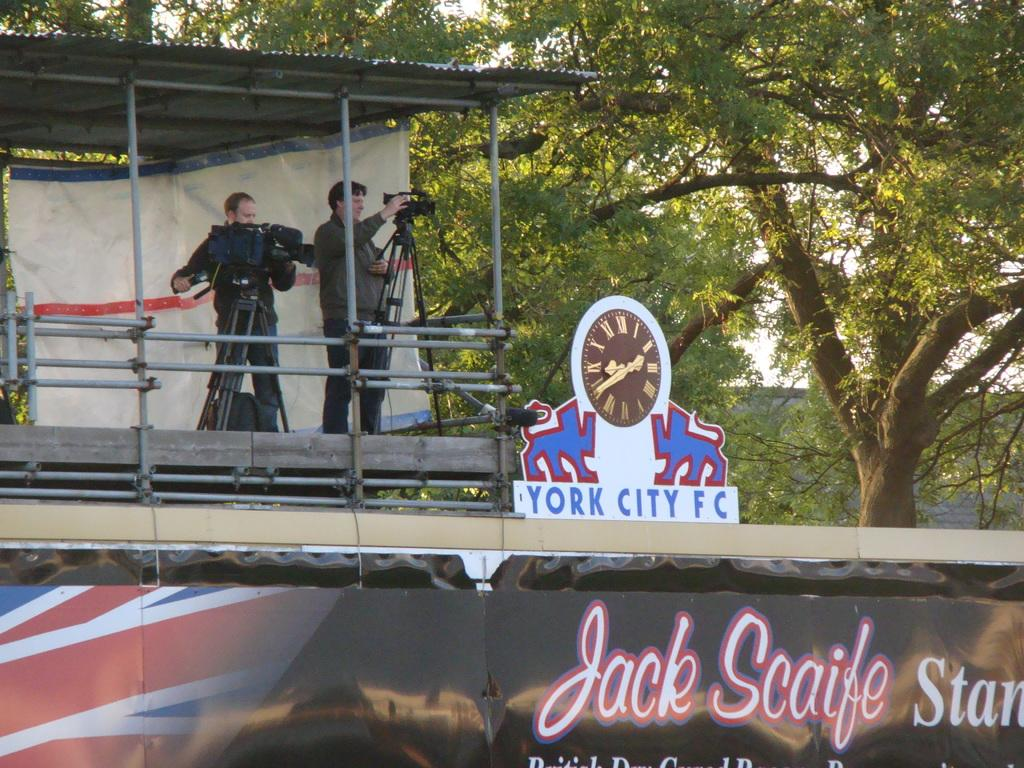<image>
Summarize the visual content of the image. A sign saying York City FC has a gold and black clock on it. 